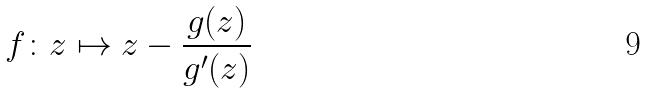<formula> <loc_0><loc_0><loc_500><loc_500>f \colon z \mapsto z - \frac { g ( z ) } { g ^ { \prime } ( z ) }</formula> 